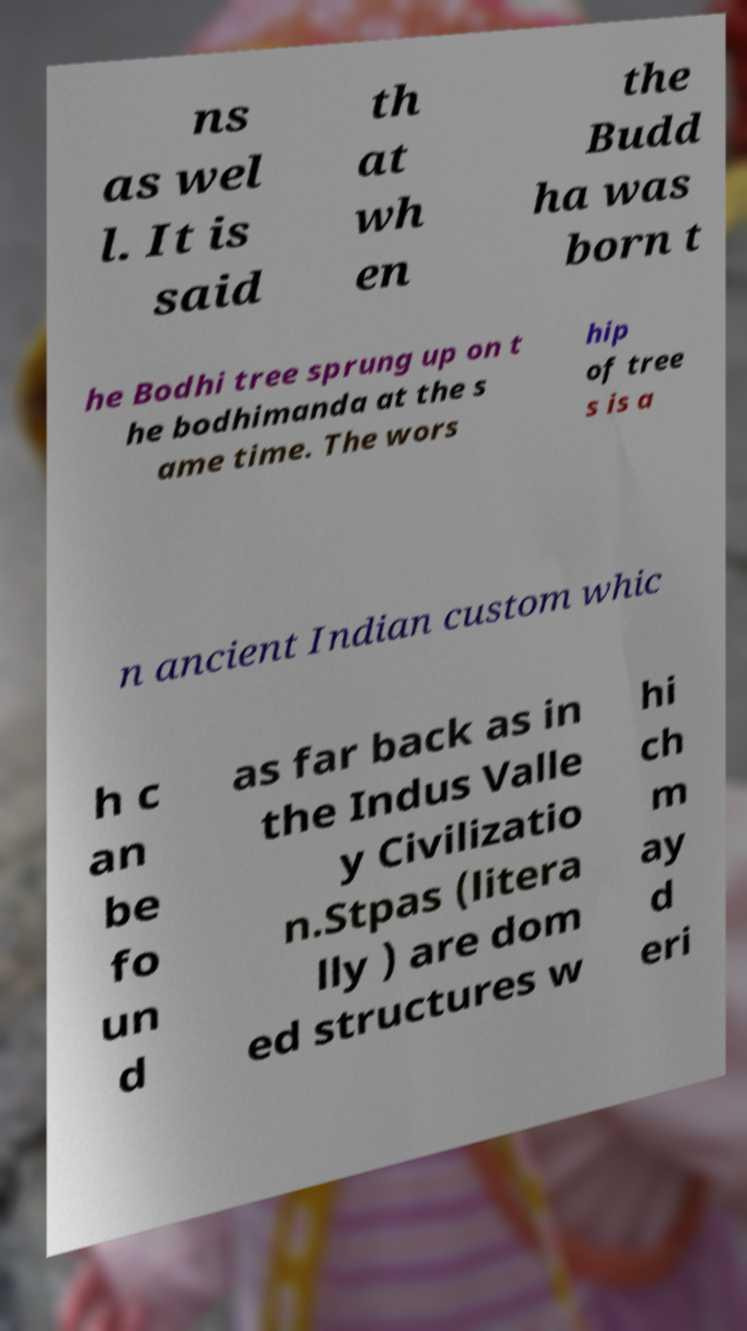Can you read and provide the text displayed in the image?This photo seems to have some interesting text. Can you extract and type it out for me? ns as wel l. It is said th at wh en the Budd ha was born t he Bodhi tree sprung up on t he bodhimanda at the s ame time. The wors hip of tree s is a n ancient Indian custom whic h c an be fo un d as far back as in the Indus Valle y Civilizatio n.Stpas (litera lly ) are dom ed structures w hi ch m ay d eri 